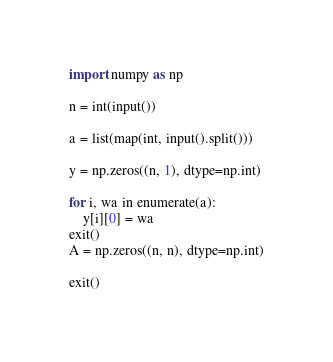Convert code to text. <code><loc_0><loc_0><loc_500><loc_500><_Python_>import numpy as np

n = int(input())

a = list(map(int, input().split()))

y = np.zeros((n, 1), dtype=np.int)

for i, wa in enumerate(a):
    y[i][0] = wa
exit()
A = np.zeros((n, n), dtype=np.int)

exit()

</code> 